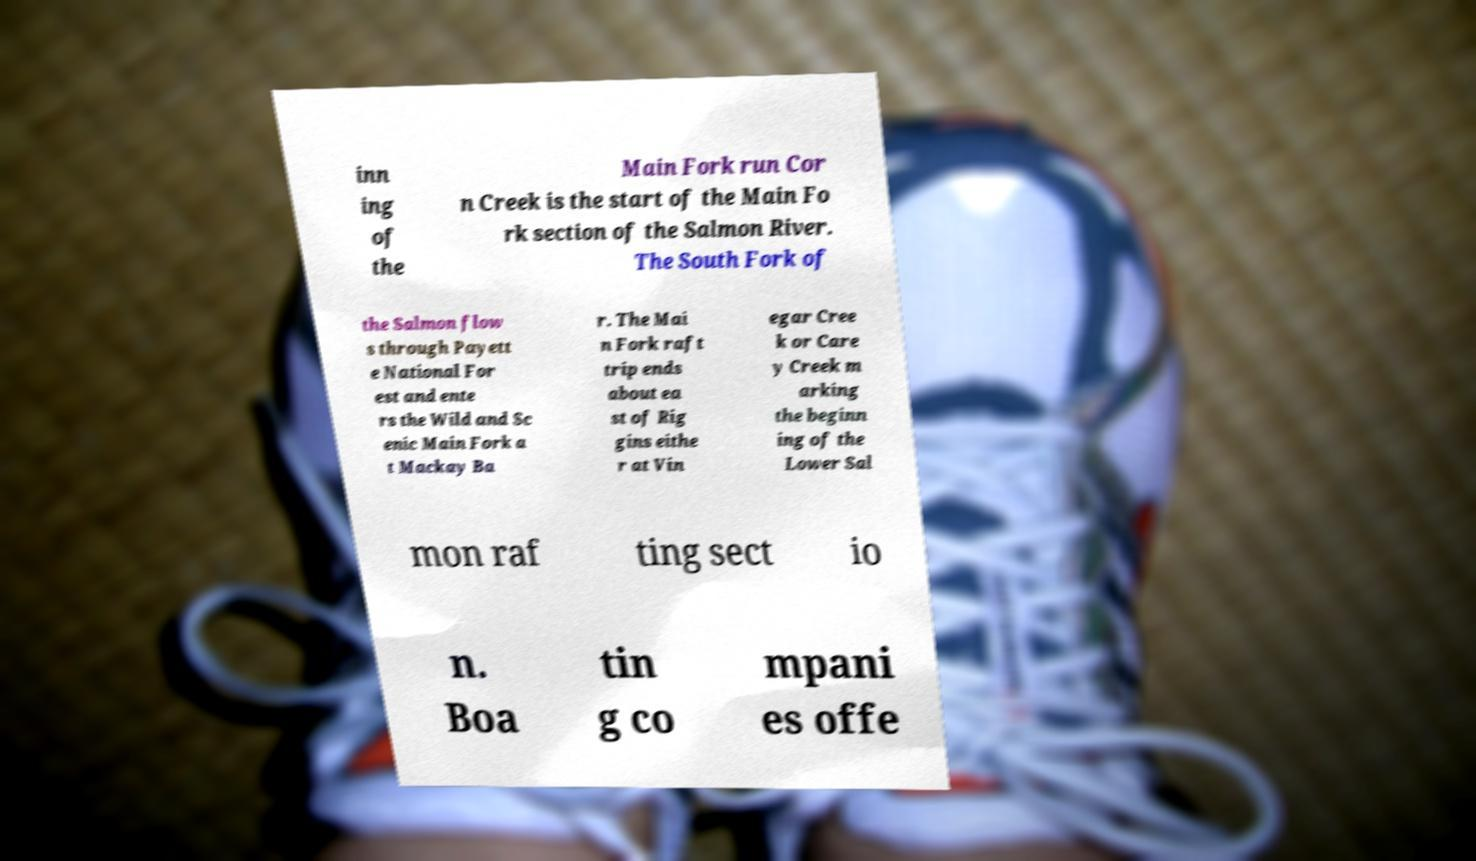Can you read and provide the text displayed in the image?This photo seems to have some interesting text. Can you extract and type it out for me? inn ing of the Main Fork run Cor n Creek is the start of the Main Fo rk section of the Salmon River. The South Fork of the Salmon flow s through Payett e National For est and ente rs the Wild and Sc enic Main Fork a t Mackay Ba r. The Mai n Fork raft trip ends about ea st of Rig gins eithe r at Vin egar Cree k or Care y Creek m arking the beginn ing of the Lower Sal mon raf ting sect io n. Boa tin g co mpani es offe 